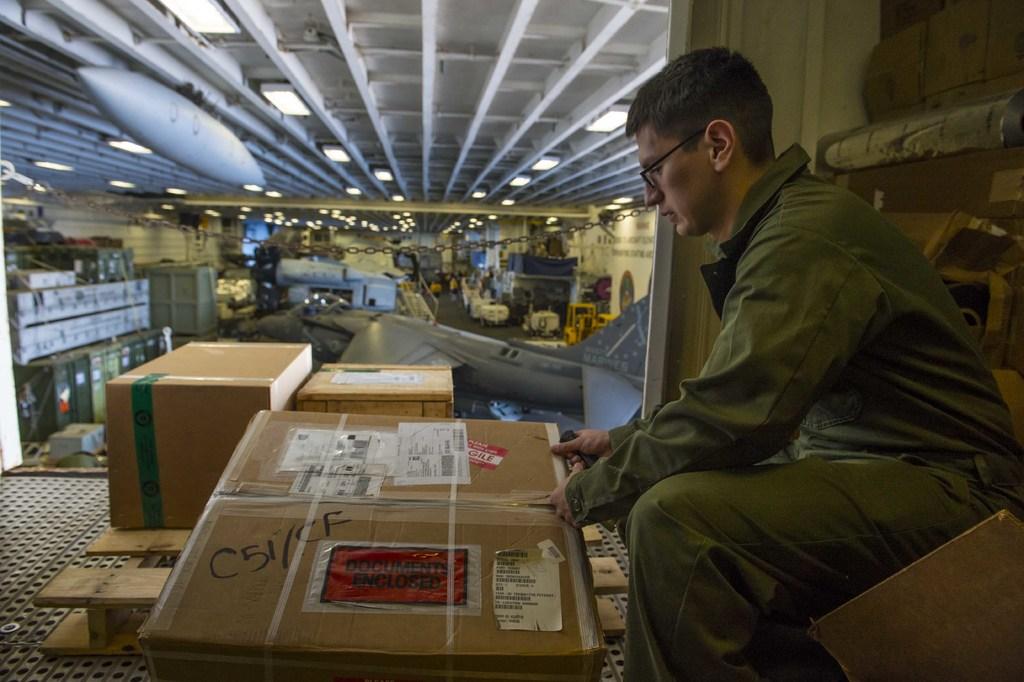What is written on the box?
Keep it short and to the point. C51/cf. What does the red label say?
Provide a short and direct response. Documents enclosed. 